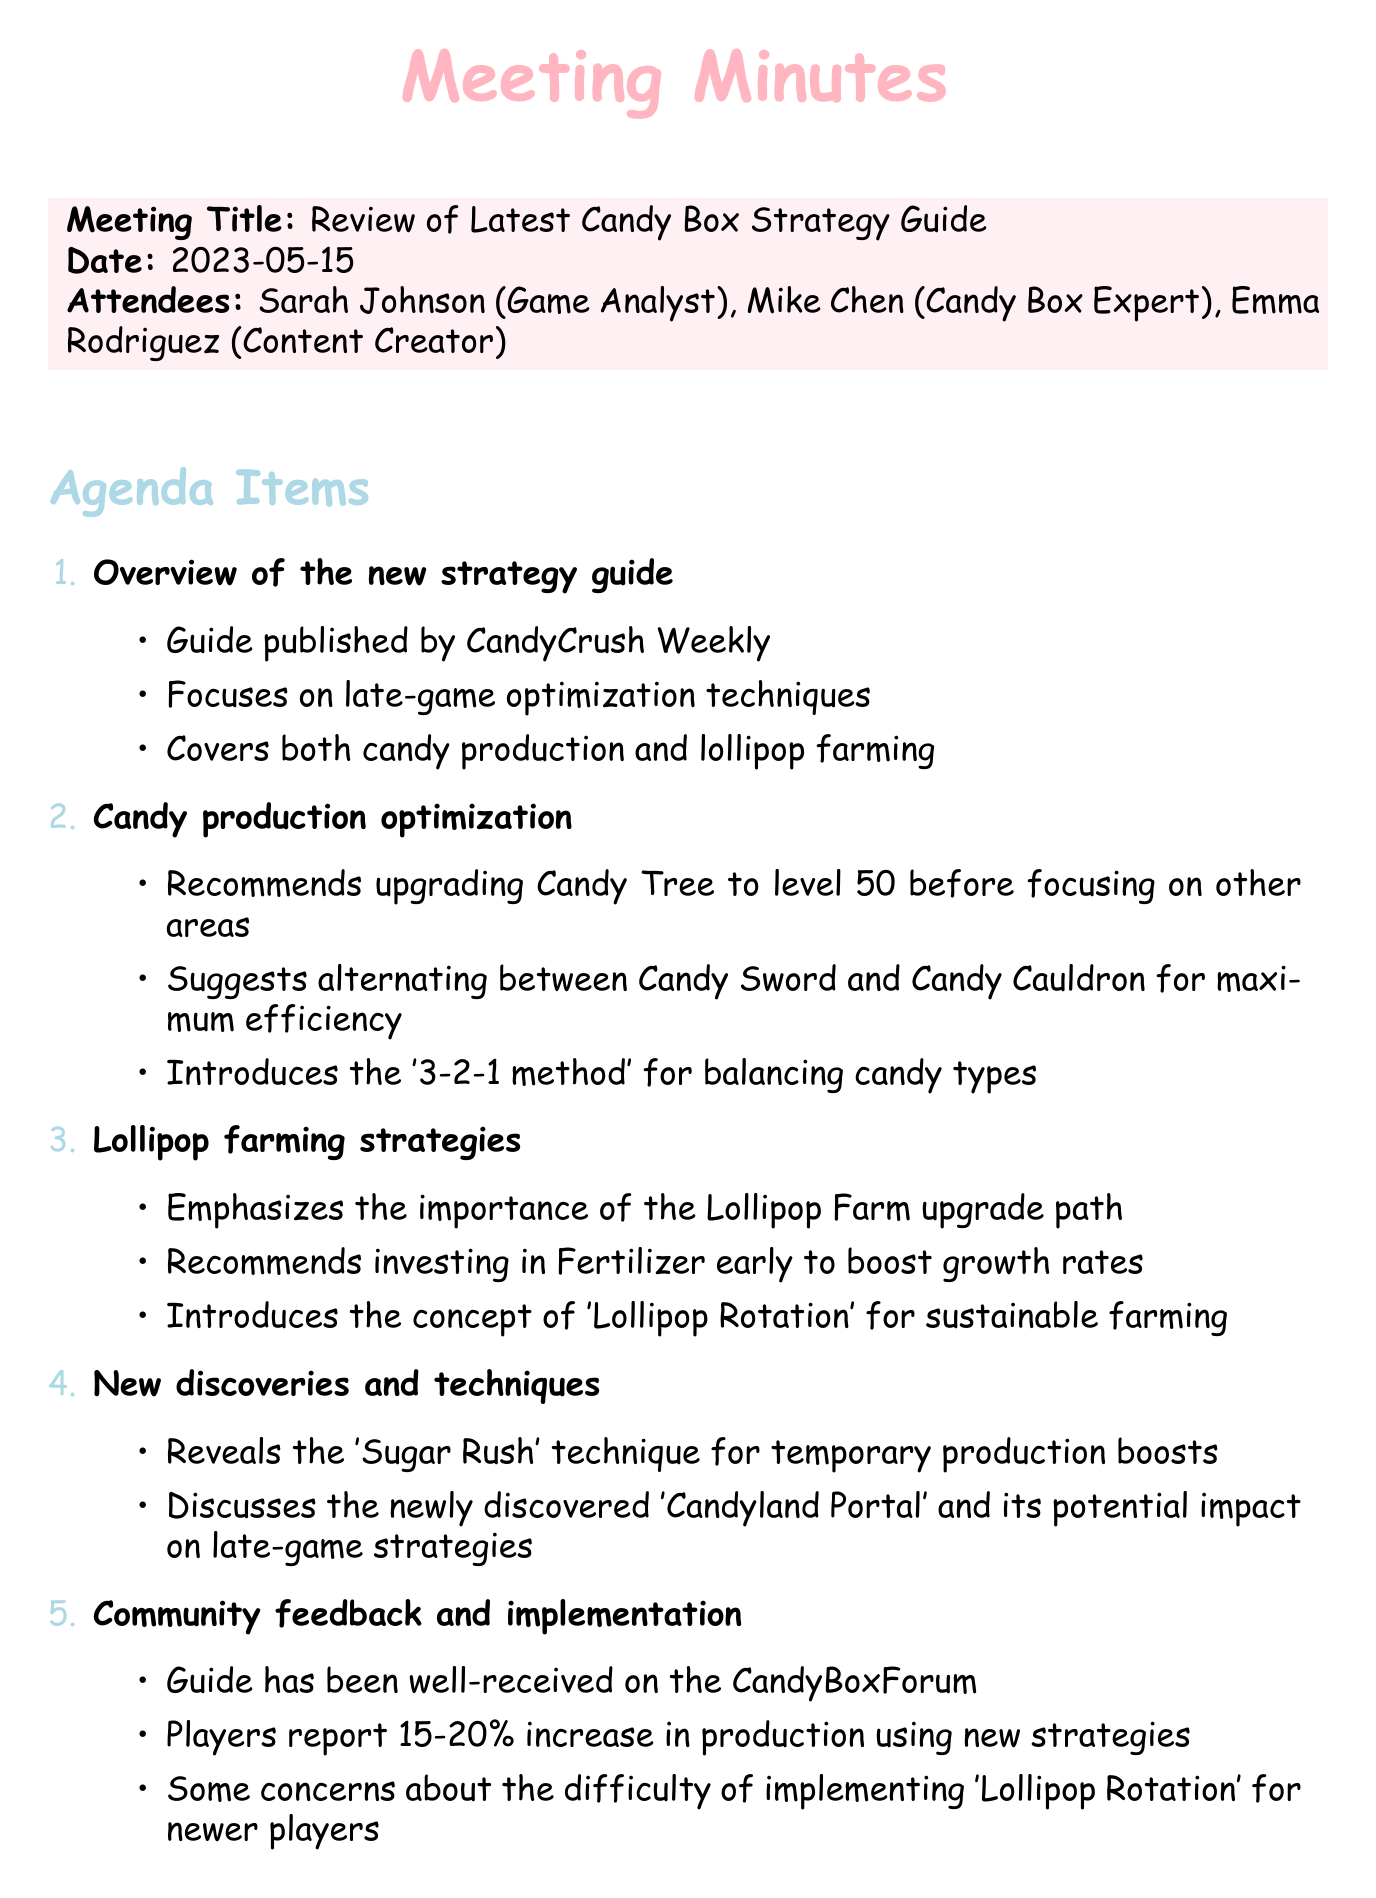What is the meeting title? The meeting title is stated clearly at the beginning of the document.
Answer: Review of Latest Candy Box Strategy Guide Who is the Candy Box Expert in the meeting? The attendees section lists the roles and names of people present in the meeting.
Answer: Mike Chen When was the meeting held? The date of the meeting is provided in the meeting details.
Answer: 2023-05-15 What is recommended to upgrade before focusing on other areas in candy production? The candy production optimization section mentions what should be upgraded first for efficiency.
Answer: Candy Tree to level 50 What percentage increase in production do players report using new strategies? The community feedback section includes the average production increase reported by players.
Answer: 15-20% What technique is introduced for balancing candy types? The candy production optimization section specifies a method for balancing candy types in gameplay.
Answer: 3-2-1 method What is the action item related to Lollipop Rotation? The action items at the end outline responsibilities determined during the meeting.
Answer: Create a beginner-friendly guide for 'Lollipop Rotation' What upgrade path is emphasized in lollipop farming strategies? The lollipop farming strategies section discusses priorities for upgrades in farming.
Answer: Lollipop Farm upgrade path What concept is introduced for sustainable farming? The lollipop farming strategies section mentions a new farming approach.
Answer: Lollipop Rotation 